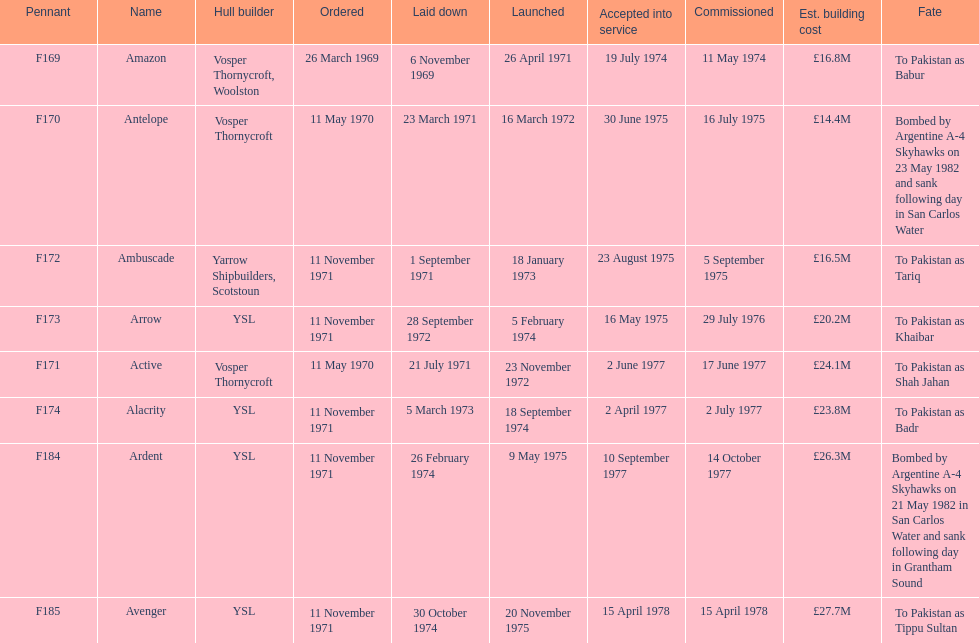What was the earlier boat? Ambuscade. 